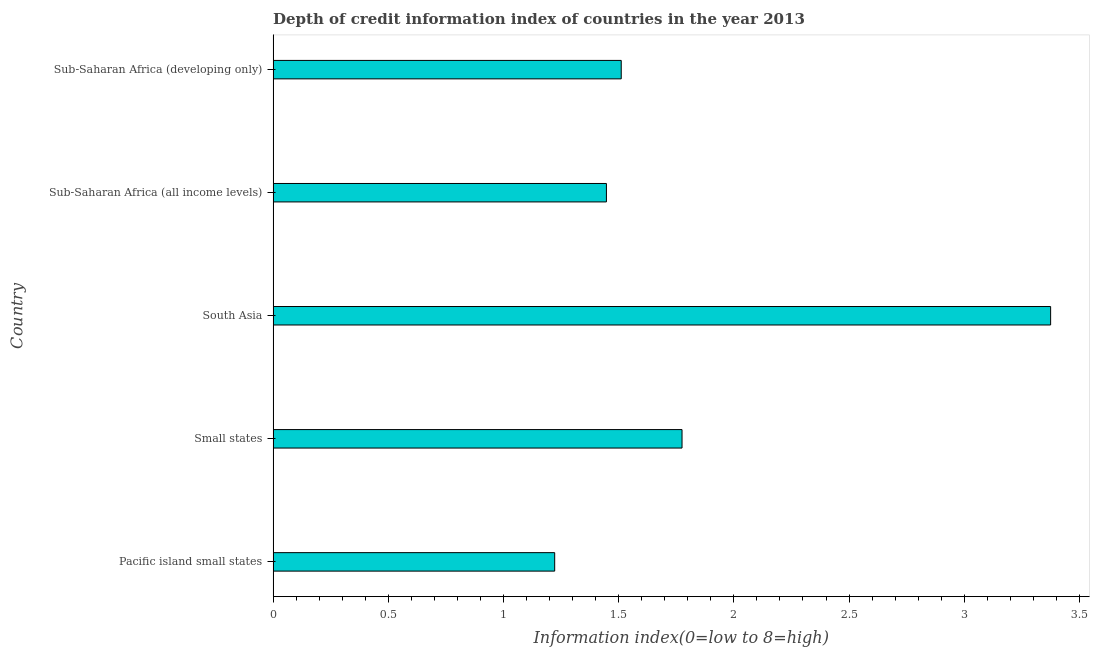What is the title of the graph?
Offer a very short reply. Depth of credit information index of countries in the year 2013. What is the label or title of the X-axis?
Your answer should be compact. Information index(0=low to 8=high). What is the label or title of the Y-axis?
Keep it short and to the point. Country. What is the depth of credit information index in Pacific island small states?
Offer a very short reply. 1.22. Across all countries, what is the maximum depth of credit information index?
Make the answer very short. 3.38. Across all countries, what is the minimum depth of credit information index?
Your answer should be compact. 1.22. In which country was the depth of credit information index maximum?
Offer a terse response. South Asia. In which country was the depth of credit information index minimum?
Give a very brief answer. Pacific island small states. What is the sum of the depth of credit information index?
Keep it short and to the point. 9.33. What is the difference between the depth of credit information index in Pacific island small states and South Asia?
Make the answer very short. -2.15. What is the average depth of credit information index per country?
Offer a terse response. 1.87. What is the median depth of credit information index?
Provide a succinct answer. 1.51. In how many countries, is the depth of credit information index greater than 0.9 ?
Give a very brief answer. 5. What is the ratio of the depth of credit information index in Sub-Saharan Africa (all income levels) to that in Sub-Saharan Africa (developing only)?
Your answer should be very brief. 0.96. Is the depth of credit information index in Sub-Saharan Africa (all income levels) less than that in Sub-Saharan Africa (developing only)?
Ensure brevity in your answer.  Yes. Is the difference between the depth of credit information index in Pacific island small states and Sub-Saharan Africa (all income levels) greater than the difference between any two countries?
Make the answer very short. No. What is the difference between the highest and the lowest depth of credit information index?
Provide a short and direct response. 2.15. In how many countries, is the depth of credit information index greater than the average depth of credit information index taken over all countries?
Ensure brevity in your answer.  1. How many bars are there?
Provide a succinct answer. 5. How many countries are there in the graph?
Offer a very short reply. 5. What is the Information index(0=low to 8=high) in Pacific island small states?
Provide a short and direct response. 1.22. What is the Information index(0=low to 8=high) in Small states?
Offer a very short reply. 1.77. What is the Information index(0=low to 8=high) of South Asia?
Provide a short and direct response. 3.38. What is the Information index(0=low to 8=high) in Sub-Saharan Africa (all income levels)?
Provide a short and direct response. 1.45. What is the Information index(0=low to 8=high) in Sub-Saharan Africa (developing only)?
Your response must be concise. 1.51. What is the difference between the Information index(0=low to 8=high) in Pacific island small states and Small states?
Your response must be concise. -0.55. What is the difference between the Information index(0=low to 8=high) in Pacific island small states and South Asia?
Your answer should be compact. -2.15. What is the difference between the Information index(0=low to 8=high) in Pacific island small states and Sub-Saharan Africa (all income levels)?
Your answer should be compact. -0.22. What is the difference between the Information index(0=low to 8=high) in Pacific island small states and Sub-Saharan Africa (developing only)?
Provide a succinct answer. -0.29. What is the difference between the Information index(0=low to 8=high) in Small states and Sub-Saharan Africa (all income levels)?
Ensure brevity in your answer.  0.33. What is the difference between the Information index(0=low to 8=high) in Small states and Sub-Saharan Africa (developing only)?
Give a very brief answer. 0.26. What is the difference between the Information index(0=low to 8=high) in South Asia and Sub-Saharan Africa (all income levels)?
Provide a short and direct response. 1.93. What is the difference between the Information index(0=low to 8=high) in South Asia and Sub-Saharan Africa (developing only)?
Offer a very short reply. 1.86. What is the difference between the Information index(0=low to 8=high) in Sub-Saharan Africa (all income levels) and Sub-Saharan Africa (developing only)?
Offer a very short reply. -0.06. What is the ratio of the Information index(0=low to 8=high) in Pacific island small states to that in Small states?
Offer a terse response. 0.69. What is the ratio of the Information index(0=low to 8=high) in Pacific island small states to that in South Asia?
Provide a short and direct response. 0.36. What is the ratio of the Information index(0=low to 8=high) in Pacific island small states to that in Sub-Saharan Africa (all income levels)?
Ensure brevity in your answer.  0.84. What is the ratio of the Information index(0=low to 8=high) in Pacific island small states to that in Sub-Saharan Africa (developing only)?
Give a very brief answer. 0.81. What is the ratio of the Information index(0=low to 8=high) in Small states to that in South Asia?
Your answer should be compact. 0.53. What is the ratio of the Information index(0=low to 8=high) in Small states to that in Sub-Saharan Africa (all income levels)?
Your answer should be compact. 1.23. What is the ratio of the Information index(0=low to 8=high) in Small states to that in Sub-Saharan Africa (developing only)?
Provide a short and direct response. 1.18. What is the ratio of the Information index(0=low to 8=high) in South Asia to that in Sub-Saharan Africa (all income levels)?
Your response must be concise. 2.33. What is the ratio of the Information index(0=low to 8=high) in South Asia to that in Sub-Saharan Africa (developing only)?
Give a very brief answer. 2.23. 